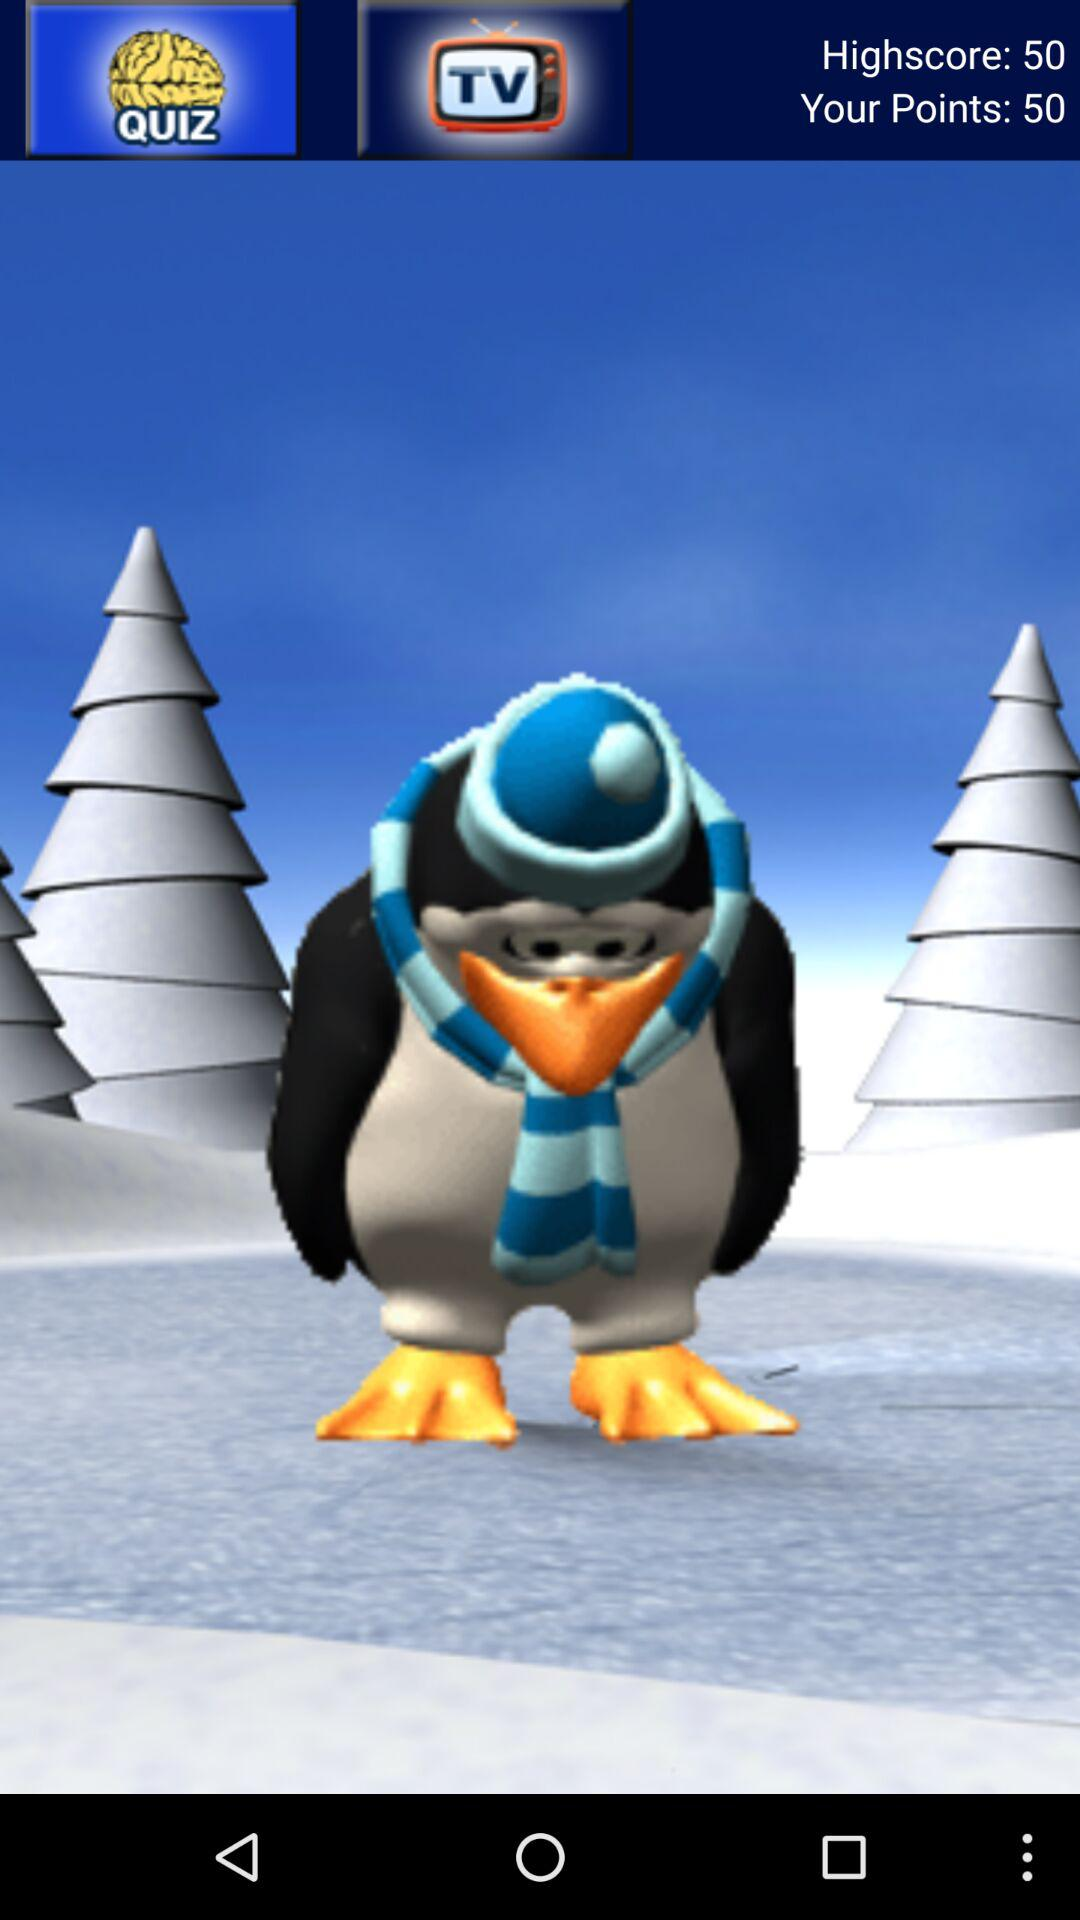What is the total points? The total points is 50. 